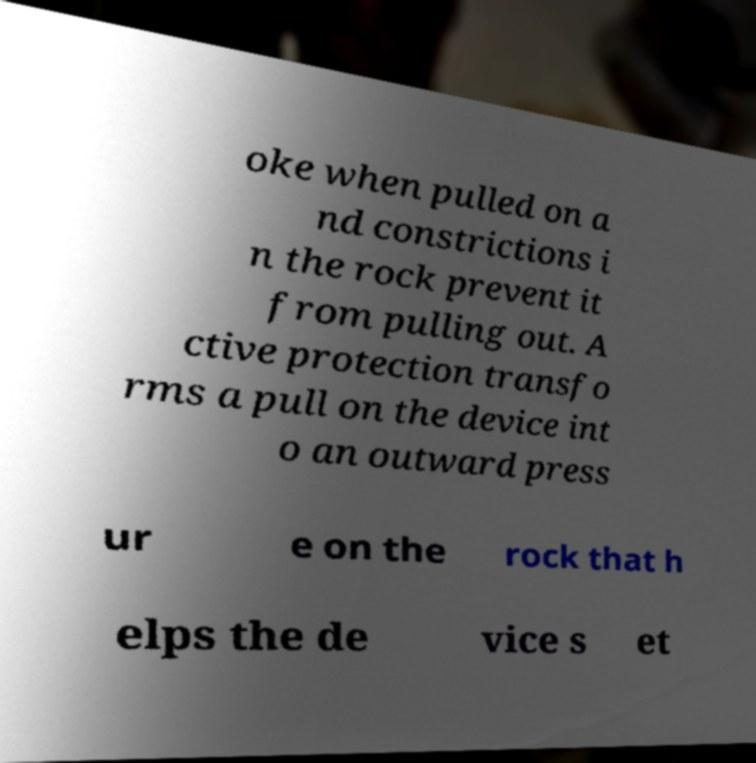For documentation purposes, I need the text within this image transcribed. Could you provide that? oke when pulled on a nd constrictions i n the rock prevent it from pulling out. A ctive protection transfo rms a pull on the device int o an outward press ur e on the rock that h elps the de vice s et 